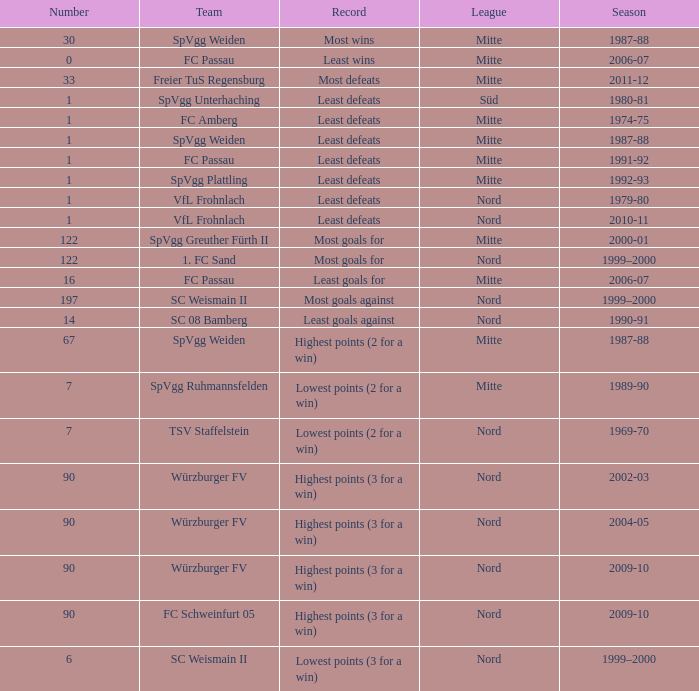What league has most wins as the record? Mitte. 